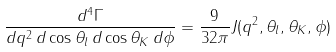<formula> <loc_0><loc_0><loc_500><loc_500>\frac { d ^ { 4 } \Gamma } { d q ^ { 2 } \, d \cos \theta _ { l } \, d \cos \theta _ { K } \, d \phi } = \frac { 9 } { 3 2 \pi } J ( q ^ { 2 } , \theta _ { l } , \theta _ { K } , \phi )</formula> 